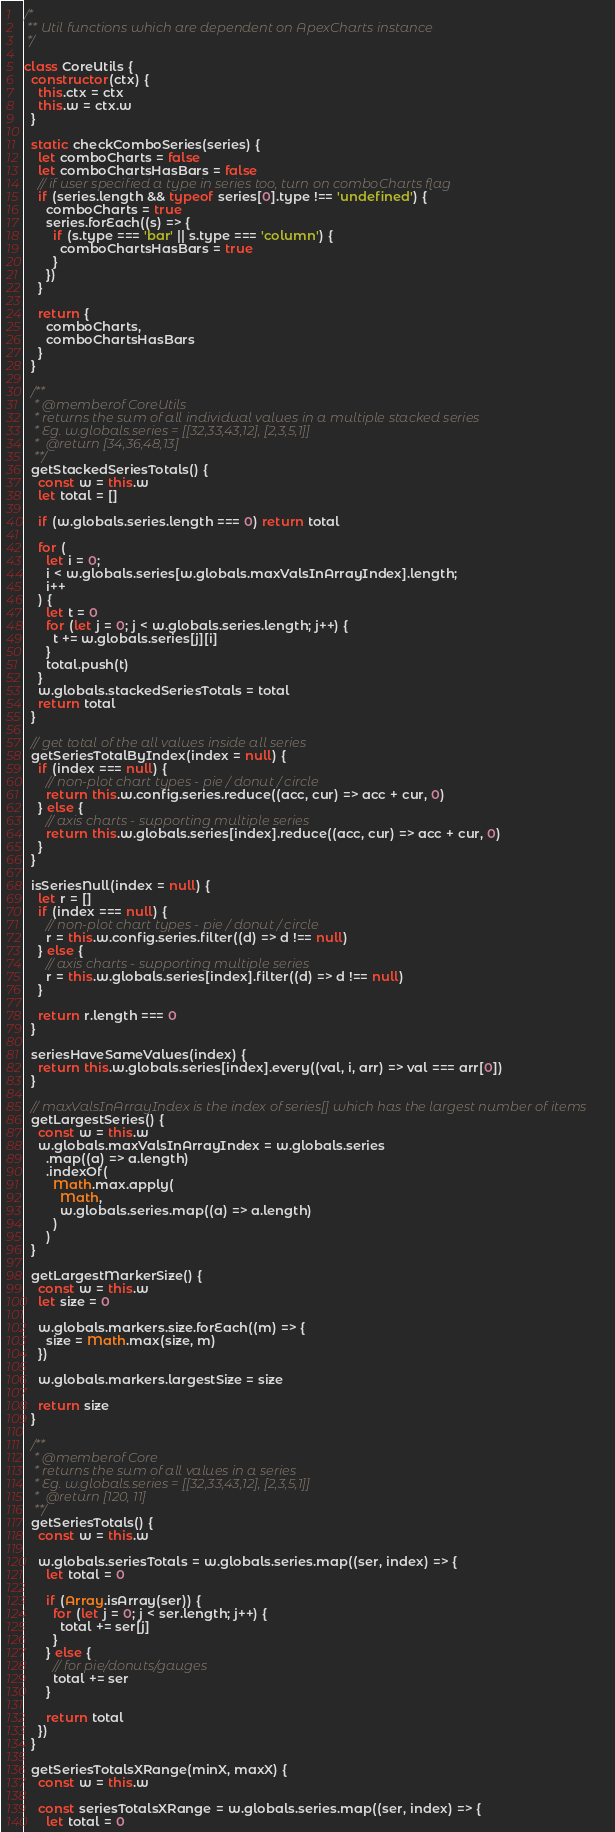Convert code to text. <code><loc_0><loc_0><loc_500><loc_500><_JavaScript_>/*
 ** Util functions which are dependent on ApexCharts instance
 */

class CoreUtils {
  constructor(ctx) {
    this.ctx = ctx
    this.w = ctx.w
  }

  static checkComboSeries(series) {
    let comboCharts = false
    let comboChartsHasBars = false
    // if user specified a type in series too, turn on comboCharts flag
    if (series.length && typeof series[0].type !== 'undefined') {
      comboCharts = true
      series.forEach((s) => {
        if (s.type === 'bar' || s.type === 'column') {
          comboChartsHasBars = true
        }
      })
    }

    return {
      comboCharts,
      comboChartsHasBars
    }
  }

  /**
   * @memberof CoreUtils
   * returns the sum of all individual values in a multiple stacked series
   * Eg. w.globals.series = [[32,33,43,12], [2,3,5,1]]
   *  @return [34,36,48,13]
   **/
  getStackedSeriesTotals() {
    const w = this.w
    let total = []

    if (w.globals.series.length === 0) return total

    for (
      let i = 0;
      i < w.globals.series[w.globals.maxValsInArrayIndex].length;
      i++
    ) {
      let t = 0
      for (let j = 0; j < w.globals.series.length; j++) {
        t += w.globals.series[j][i]
      }
      total.push(t)
    }
    w.globals.stackedSeriesTotals = total
    return total
  }

  // get total of the all values inside all series
  getSeriesTotalByIndex(index = null) {
    if (index === null) {
      // non-plot chart types - pie / donut / circle
      return this.w.config.series.reduce((acc, cur) => acc + cur, 0)
    } else {
      // axis charts - supporting multiple series
      return this.w.globals.series[index].reduce((acc, cur) => acc + cur, 0)
    }
  }

  isSeriesNull(index = null) {
    let r = []
    if (index === null) {
      // non-plot chart types - pie / donut / circle
      r = this.w.config.series.filter((d) => d !== null)
    } else {
      // axis charts - supporting multiple series
      r = this.w.globals.series[index].filter((d) => d !== null)
    }

    return r.length === 0
  }

  seriesHaveSameValues(index) {
    return this.w.globals.series[index].every((val, i, arr) => val === arr[0])
  }

  // maxValsInArrayIndex is the index of series[] which has the largest number of items
  getLargestSeries() {
    const w = this.w
    w.globals.maxValsInArrayIndex = w.globals.series
      .map((a) => a.length)
      .indexOf(
        Math.max.apply(
          Math,
          w.globals.series.map((a) => a.length)
        )
      )
  }

  getLargestMarkerSize() {
    const w = this.w
    let size = 0

    w.globals.markers.size.forEach((m) => {
      size = Math.max(size, m)
    })

    w.globals.markers.largestSize = size

    return size
  }

  /**
   * @memberof Core
   * returns the sum of all values in a series
   * Eg. w.globals.series = [[32,33,43,12], [2,3,5,1]]
   *  @return [120, 11]
   **/
  getSeriesTotals() {
    const w = this.w

    w.globals.seriesTotals = w.globals.series.map((ser, index) => {
      let total = 0

      if (Array.isArray(ser)) {
        for (let j = 0; j < ser.length; j++) {
          total += ser[j]
        }
      } else {
        // for pie/donuts/gauges
        total += ser
      }

      return total
    })
  }

  getSeriesTotalsXRange(minX, maxX) {
    const w = this.w

    const seriesTotalsXRange = w.globals.series.map((ser, index) => {
      let total = 0
</code> 